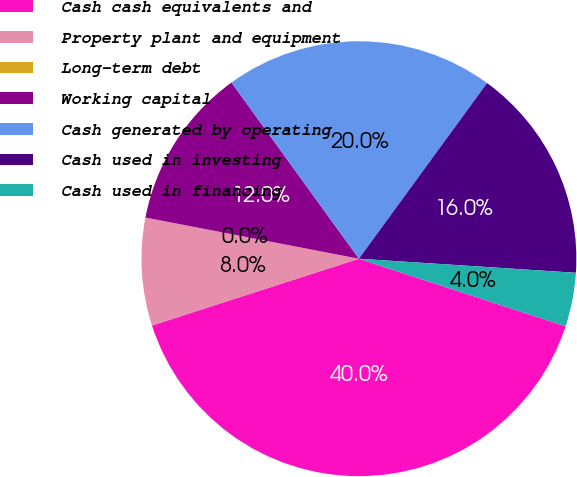Convert chart to OTSL. <chart><loc_0><loc_0><loc_500><loc_500><pie_chart><fcel>Cash cash equivalents and<fcel>Property plant and equipment<fcel>Long-term debt<fcel>Working capital<fcel>Cash generated by operating<fcel>Cash used in investing<fcel>Cash used in financing<nl><fcel>40.0%<fcel>8.0%<fcel>0.0%<fcel>12.0%<fcel>20.0%<fcel>16.0%<fcel>4.0%<nl></chart> 